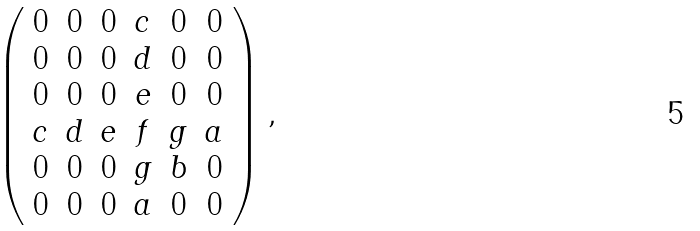Convert formula to latex. <formula><loc_0><loc_0><loc_500><loc_500>\left ( \begin{array} { c c c c c c } 0 & 0 & 0 & c & 0 & 0 \\ 0 & 0 & 0 & d & 0 & 0 \\ 0 & 0 & 0 & e & 0 & 0 \\ c & d & e & f & g & a \\ 0 & 0 & 0 & g & b & 0 \\ 0 & 0 & 0 & a & 0 & 0 \end{array} \right ) ,</formula> 